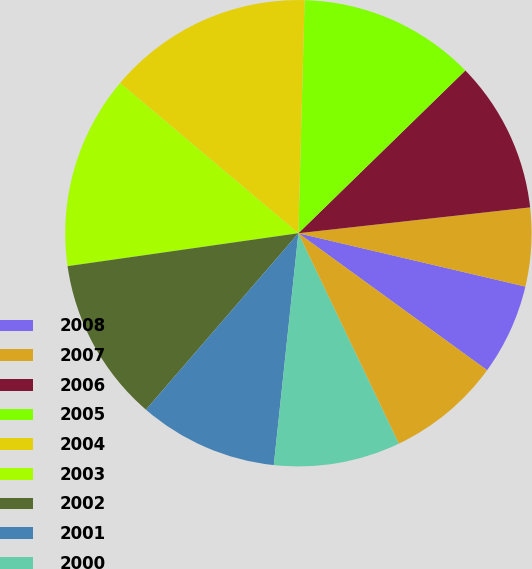Convert chart to OTSL. <chart><loc_0><loc_0><loc_500><loc_500><pie_chart><fcel>2008<fcel>2007<fcel>2006<fcel>2005<fcel>2004<fcel>2003<fcel>2002<fcel>2001<fcel>2000<fcel>1999<nl><fcel>6.32%<fcel>5.44%<fcel>10.53%<fcel>12.28%<fcel>14.28%<fcel>13.4%<fcel>11.4%<fcel>9.66%<fcel>8.78%<fcel>7.91%<nl></chart> 